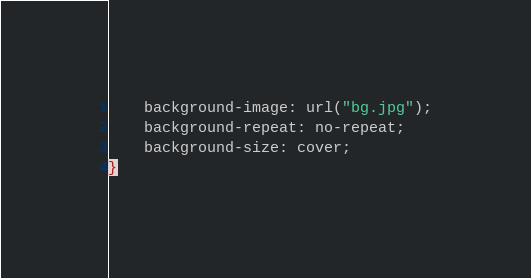Convert code to text. <code><loc_0><loc_0><loc_500><loc_500><_CSS_>	background-image: url("bg.jpg");
	background-repeat: no-repeat;
	background-size: cover;
}</code> 